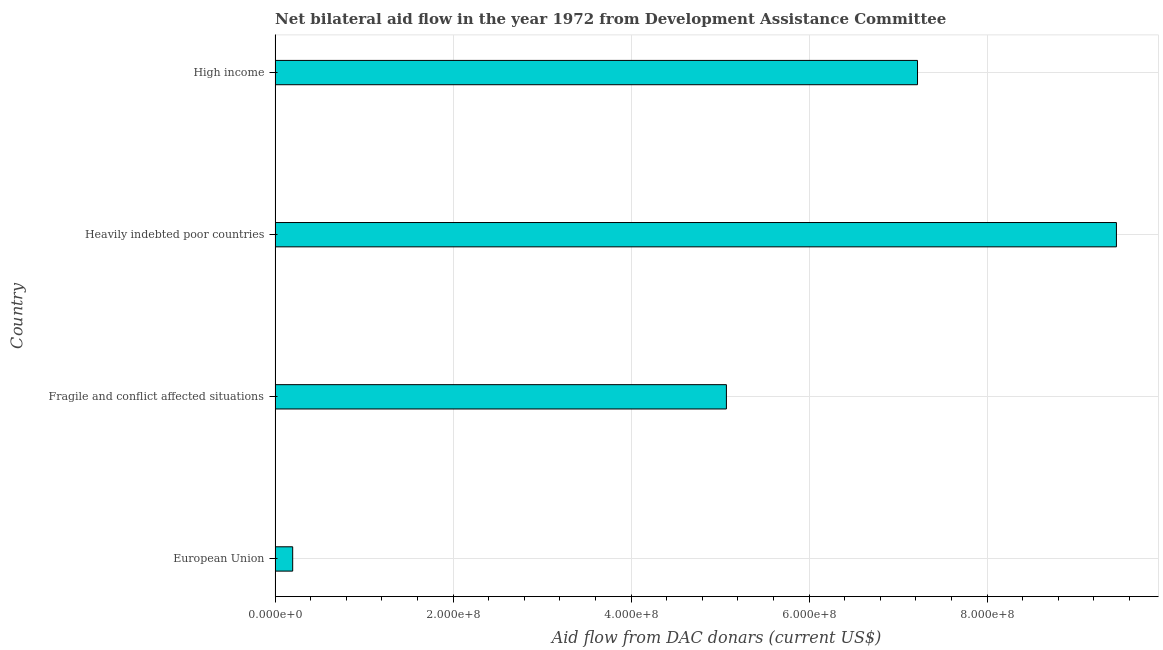Does the graph contain grids?
Provide a short and direct response. Yes. What is the title of the graph?
Your response must be concise. Net bilateral aid flow in the year 1972 from Development Assistance Committee. What is the label or title of the X-axis?
Make the answer very short. Aid flow from DAC donars (current US$). What is the label or title of the Y-axis?
Your response must be concise. Country. What is the net bilateral aid flows from dac donors in European Union?
Offer a terse response. 1.98e+07. Across all countries, what is the maximum net bilateral aid flows from dac donors?
Provide a succinct answer. 9.45e+08. Across all countries, what is the minimum net bilateral aid flows from dac donors?
Ensure brevity in your answer.  1.98e+07. In which country was the net bilateral aid flows from dac donors maximum?
Offer a very short reply. Heavily indebted poor countries. In which country was the net bilateral aid flows from dac donors minimum?
Your answer should be compact. European Union. What is the sum of the net bilateral aid flows from dac donors?
Offer a very short reply. 2.19e+09. What is the difference between the net bilateral aid flows from dac donors in Fragile and conflict affected situations and High income?
Provide a succinct answer. -2.15e+08. What is the average net bilateral aid flows from dac donors per country?
Ensure brevity in your answer.  5.49e+08. What is the median net bilateral aid flows from dac donors?
Ensure brevity in your answer.  6.15e+08. What is the ratio of the net bilateral aid flows from dac donors in European Union to that in Fragile and conflict affected situations?
Provide a succinct answer. 0.04. Is the difference between the net bilateral aid flows from dac donors in European Union and Heavily indebted poor countries greater than the difference between any two countries?
Offer a terse response. Yes. What is the difference between the highest and the second highest net bilateral aid flows from dac donors?
Make the answer very short. 2.24e+08. What is the difference between the highest and the lowest net bilateral aid flows from dac donors?
Offer a very short reply. 9.26e+08. How many bars are there?
Your response must be concise. 4. Are the values on the major ticks of X-axis written in scientific E-notation?
Your answer should be very brief. Yes. What is the Aid flow from DAC donars (current US$) in European Union?
Make the answer very short. 1.98e+07. What is the Aid flow from DAC donars (current US$) of Fragile and conflict affected situations?
Your response must be concise. 5.07e+08. What is the Aid flow from DAC donars (current US$) of Heavily indebted poor countries?
Offer a very short reply. 9.45e+08. What is the Aid flow from DAC donars (current US$) in High income?
Keep it short and to the point. 7.22e+08. What is the difference between the Aid flow from DAC donars (current US$) in European Union and Fragile and conflict affected situations?
Provide a succinct answer. -4.87e+08. What is the difference between the Aid flow from DAC donars (current US$) in European Union and Heavily indebted poor countries?
Provide a succinct answer. -9.26e+08. What is the difference between the Aid flow from DAC donars (current US$) in European Union and High income?
Provide a short and direct response. -7.02e+08. What is the difference between the Aid flow from DAC donars (current US$) in Fragile and conflict affected situations and Heavily indebted poor countries?
Provide a short and direct response. -4.38e+08. What is the difference between the Aid flow from DAC donars (current US$) in Fragile and conflict affected situations and High income?
Give a very brief answer. -2.15e+08. What is the difference between the Aid flow from DAC donars (current US$) in Heavily indebted poor countries and High income?
Give a very brief answer. 2.24e+08. What is the ratio of the Aid flow from DAC donars (current US$) in European Union to that in Fragile and conflict affected situations?
Offer a very short reply. 0.04. What is the ratio of the Aid flow from DAC donars (current US$) in European Union to that in Heavily indebted poor countries?
Offer a terse response. 0.02. What is the ratio of the Aid flow from DAC donars (current US$) in European Union to that in High income?
Give a very brief answer. 0.03. What is the ratio of the Aid flow from DAC donars (current US$) in Fragile and conflict affected situations to that in Heavily indebted poor countries?
Your answer should be compact. 0.54. What is the ratio of the Aid flow from DAC donars (current US$) in Fragile and conflict affected situations to that in High income?
Ensure brevity in your answer.  0.7. What is the ratio of the Aid flow from DAC donars (current US$) in Heavily indebted poor countries to that in High income?
Offer a terse response. 1.31. 